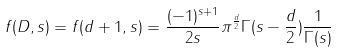<formula> <loc_0><loc_0><loc_500><loc_500>f ( D , s ) = f ( d + 1 , s ) = \frac { ( - 1 ) ^ { s + 1 } } { 2 s } \pi ^ { \frac { d } { 2 } } \Gamma ( s - \frac { d } { 2 } ) \frac { 1 } { \Gamma ( s ) }</formula> 